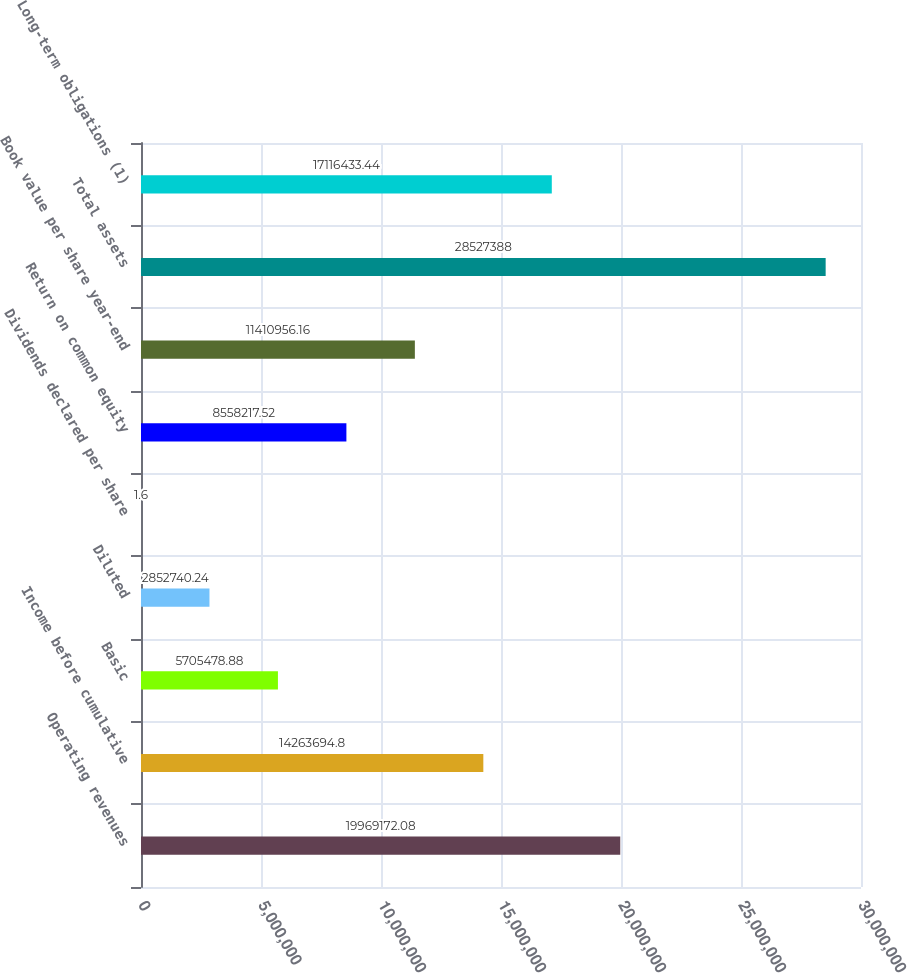Convert chart to OTSL. <chart><loc_0><loc_0><loc_500><loc_500><bar_chart><fcel>Operating revenues<fcel>Income before cumulative<fcel>Basic<fcel>Diluted<fcel>Dividends declared per share<fcel>Return on common equity<fcel>Book value per share year-end<fcel>Total assets<fcel>Long-term obligations (1)<nl><fcel>1.99692e+07<fcel>1.42637e+07<fcel>5.70548e+06<fcel>2.85274e+06<fcel>1.6<fcel>8.55822e+06<fcel>1.1411e+07<fcel>2.85274e+07<fcel>1.71164e+07<nl></chart> 